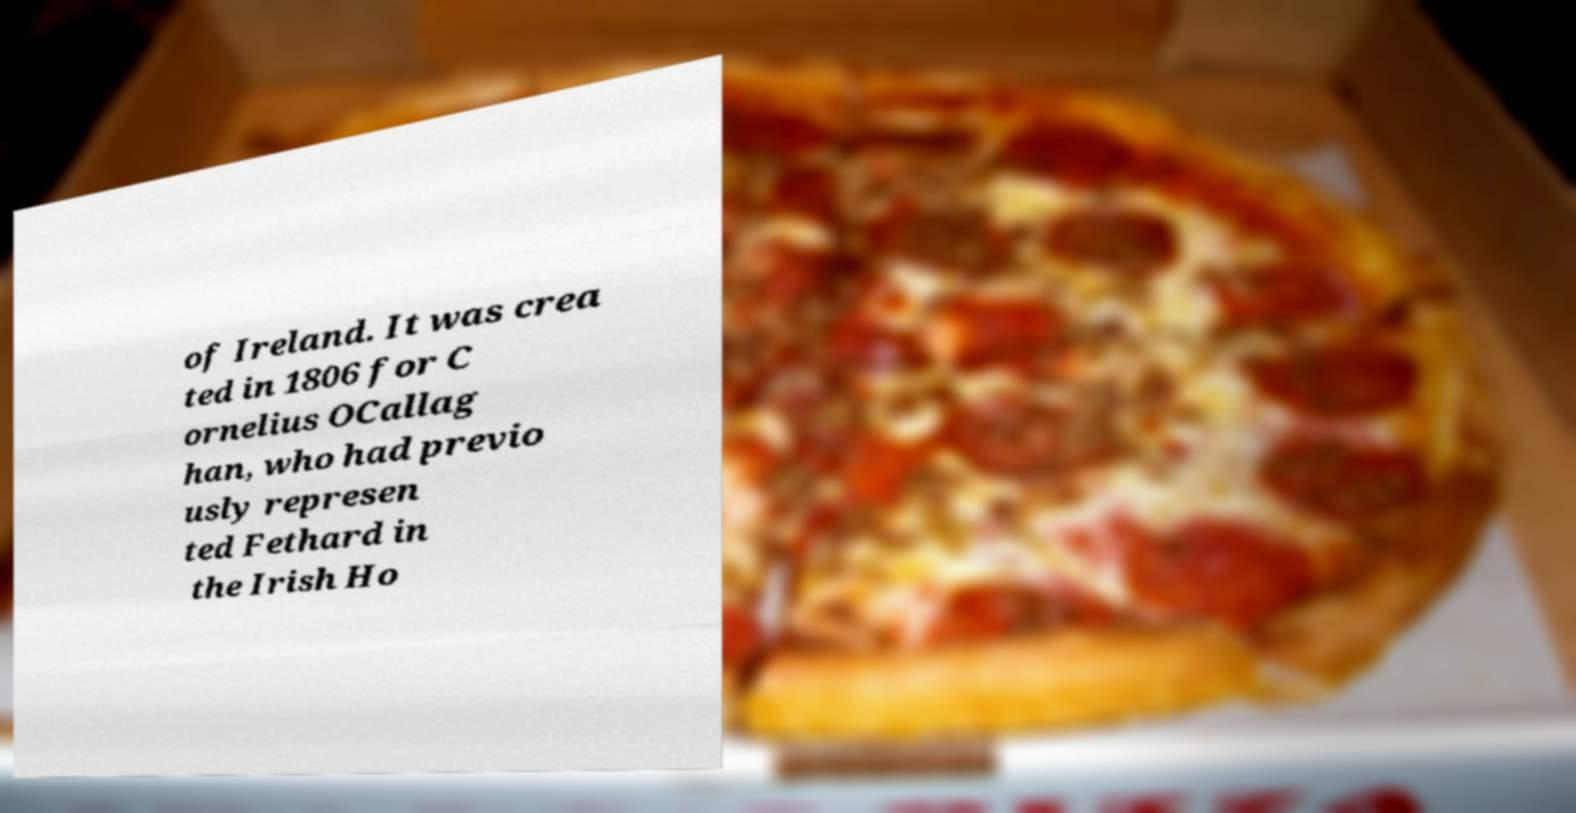Could you assist in decoding the text presented in this image and type it out clearly? of Ireland. It was crea ted in 1806 for C ornelius OCallag han, who had previo usly represen ted Fethard in the Irish Ho 